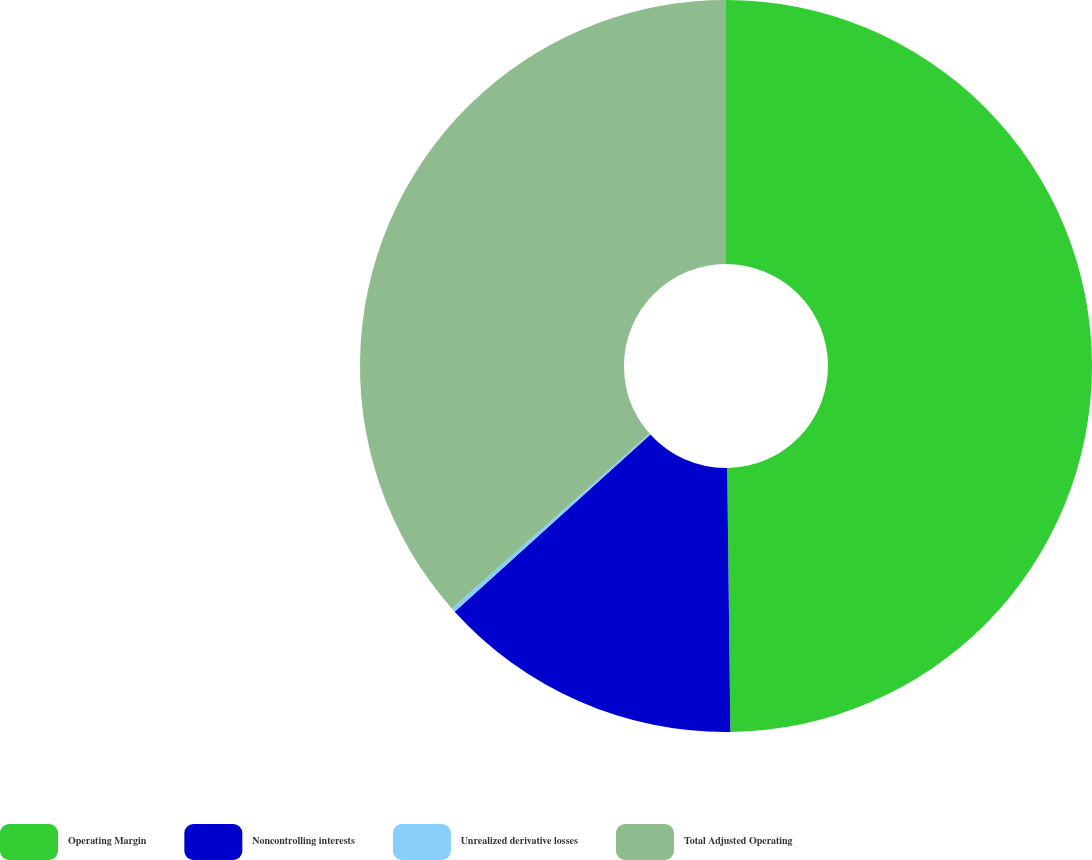Convert chart. <chart><loc_0><loc_0><loc_500><loc_500><pie_chart><fcel>Operating Margin<fcel>Noncontrolling interests<fcel>Unrealized derivative losses<fcel>Total Adjusted Operating<nl><fcel>49.81%<fcel>13.48%<fcel>0.19%<fcel>36.52%<nl></chart> 